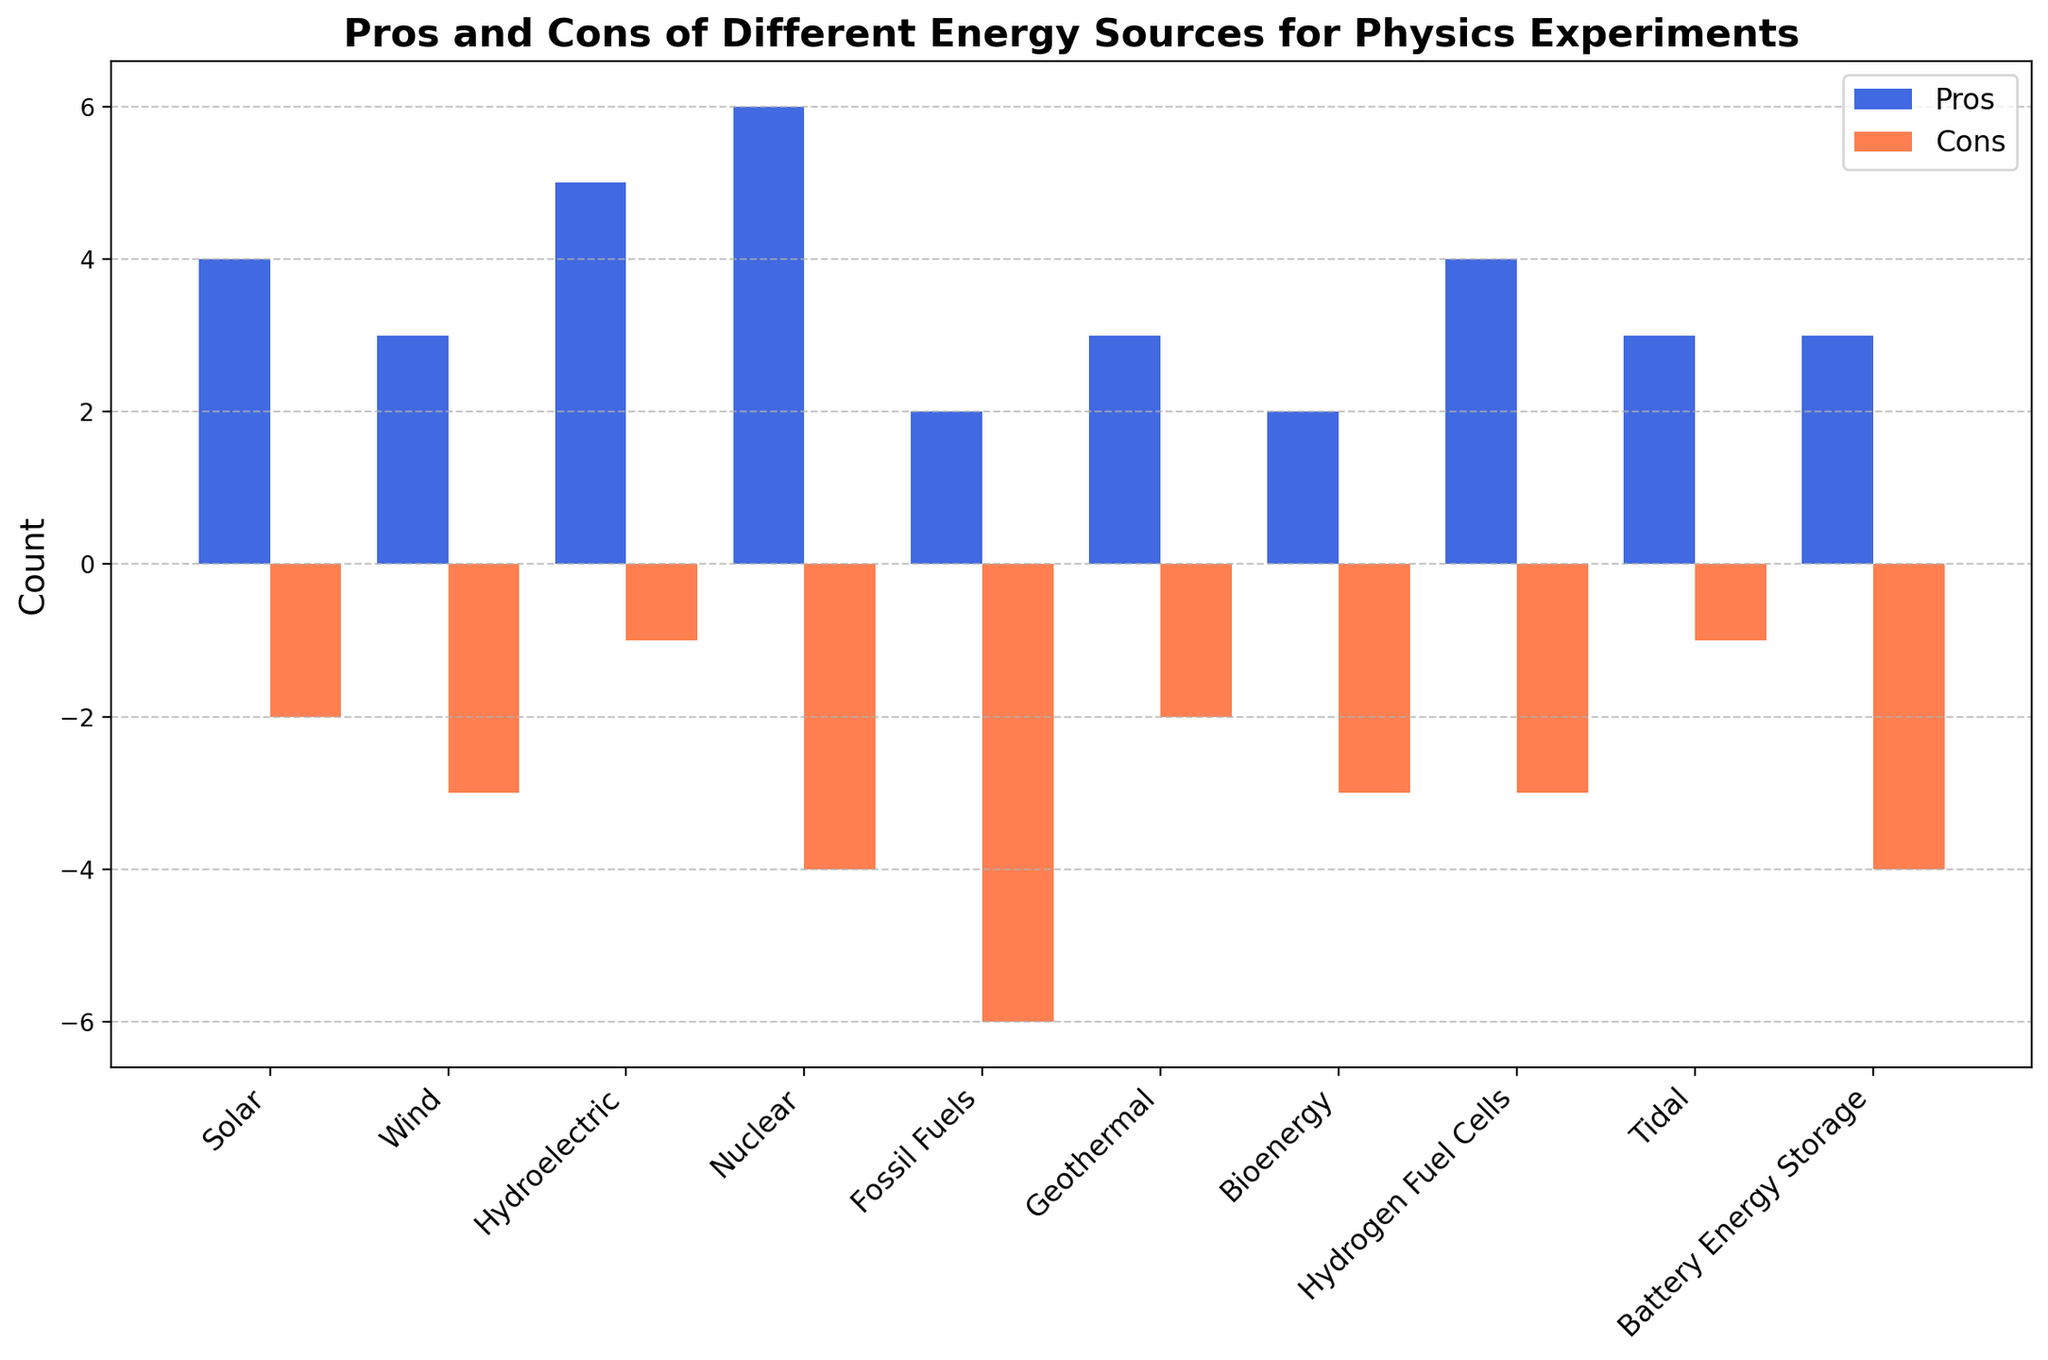Which energy source has the highest number of pros? The bar representing "Nuclear" energy is the tallest in the Pros category.
Answer: Nuclear Which energy source has the lowest number of cons? The bar representing "Hydroelectric" energy is the shortest in the Cons category.
Answer: Hydroelectric What is the difference between the number of pros and cons for Fossil Fuels? The height of the Pros bar for "Fossil Fuels" is 2, and the height of the Cons bar is -6. The difference is 2 - (-6) = 2 + 6.
Answer: 8 Compare the number of pros for Solar and Wind energy sources. Which one has more? The height of the Pros bar for "Solar" is greater than that of "Wind".
Answer: Solar What is the average number of pros across all energy sources? Sum the number of pros for all energy sources: 4 + 3 + 5 + 6 + 2 + 3 + 2 + 4 + 3 + 3 = 35. Then divide by the number of energy sources: 35 / 10.
Answer: 3.5 Which energy source has more pros, Geothermal or Bioenergy? The height of the Pros bar for "Geothermal" is greater than that of "Bioenergy".
Answer: Geothermal How many energy sources have a cons value of -3? Count the bars in the Cons category with a value of -3. These include Wind, Bioenergy, and Hydrogen Fuel Cells.
Answer: 3 Is the number of cons for Battery Energy Storage greater or less than that for Hydrogen Fuel Cells? Compare the height of the Cons bar for "Battery Energy Storage" (-4) with "Hydrogen Fuel Cells" (-3). -4 is less than -3.
Answer: Less 